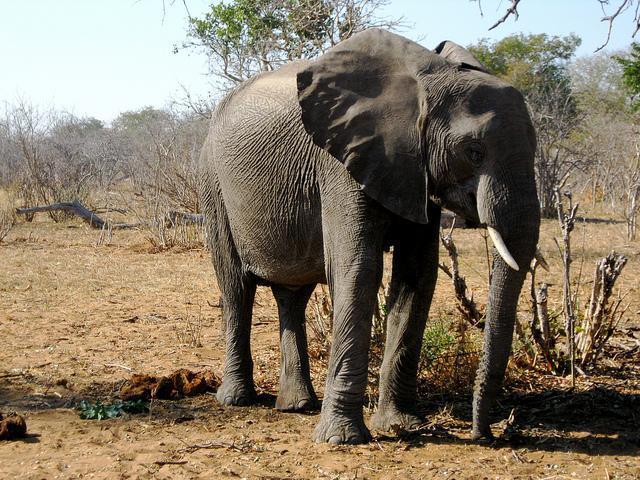How many motorcycles in the picture?
Give a very brief answer. 0. 